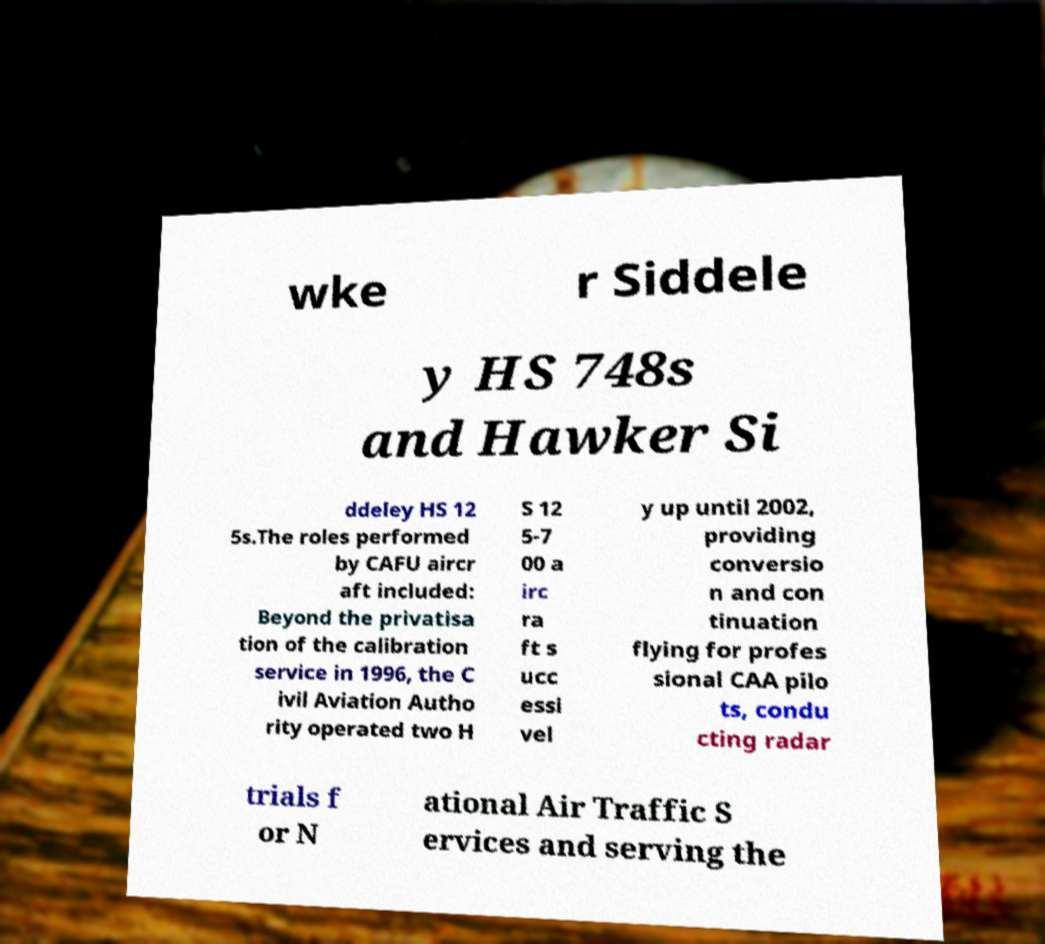For documentation purposes, I need the text within this image transcribed. Could you provide that? wke r Siddele y HS 748s and Hawker Si ddeley HS 12 5s.The roles performed by CAFU aircr aft included: Beyond the privatisa tion of the calibration service in 1996, the C ivil Aviation Autho rity operated two H S 12 5-7 00 a irc ra ft s ucc essi vel y up until 2002, providing conversio n and con tinuation flying for profes sional CAA pilo ts, condu cting radar trials f or N ational Air Traffic S ervices and serving the 